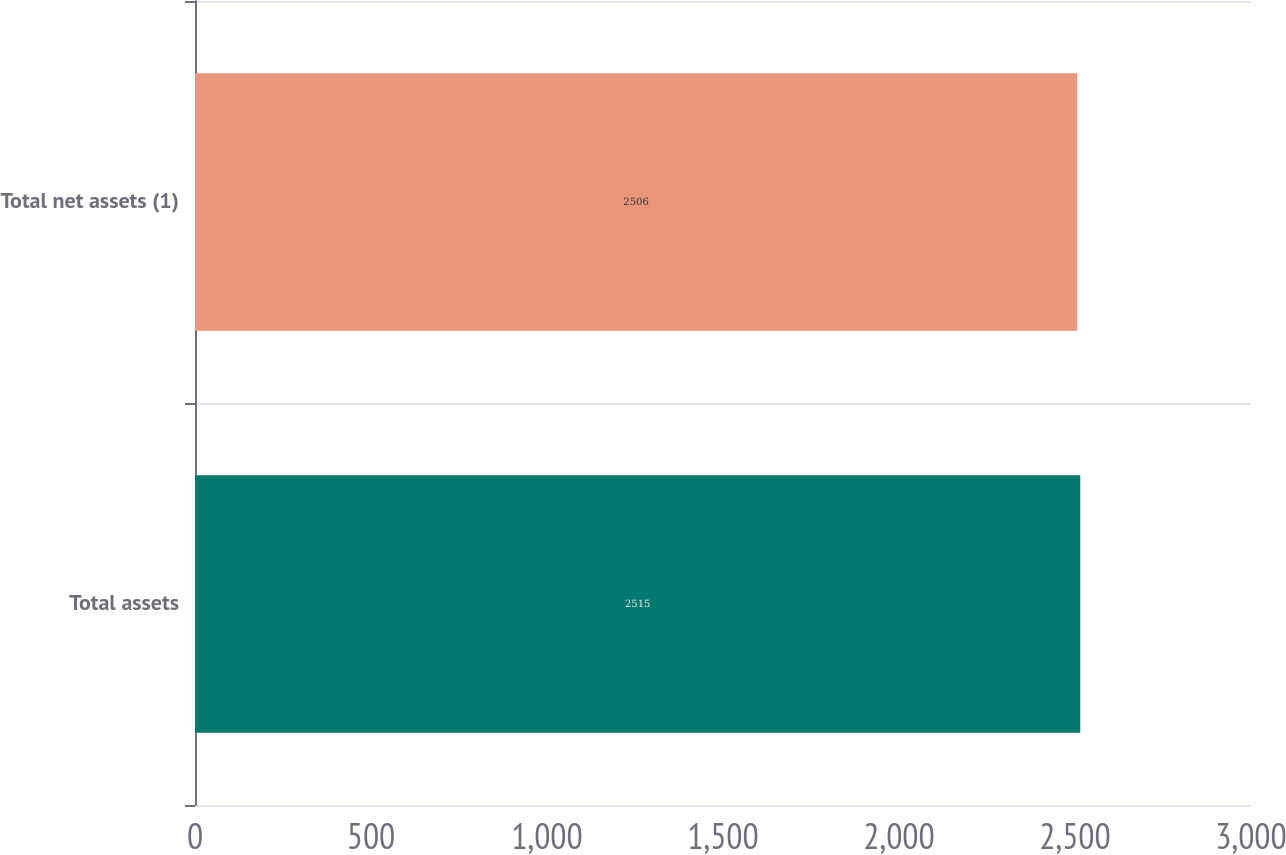<chart> <loc_0><loc_0><loc_500><loc_500><bar_chart><fcel>Total assets<fcel>Total net assets (1)<nl><fcel>2515<fcel>2506<nl></chart> 